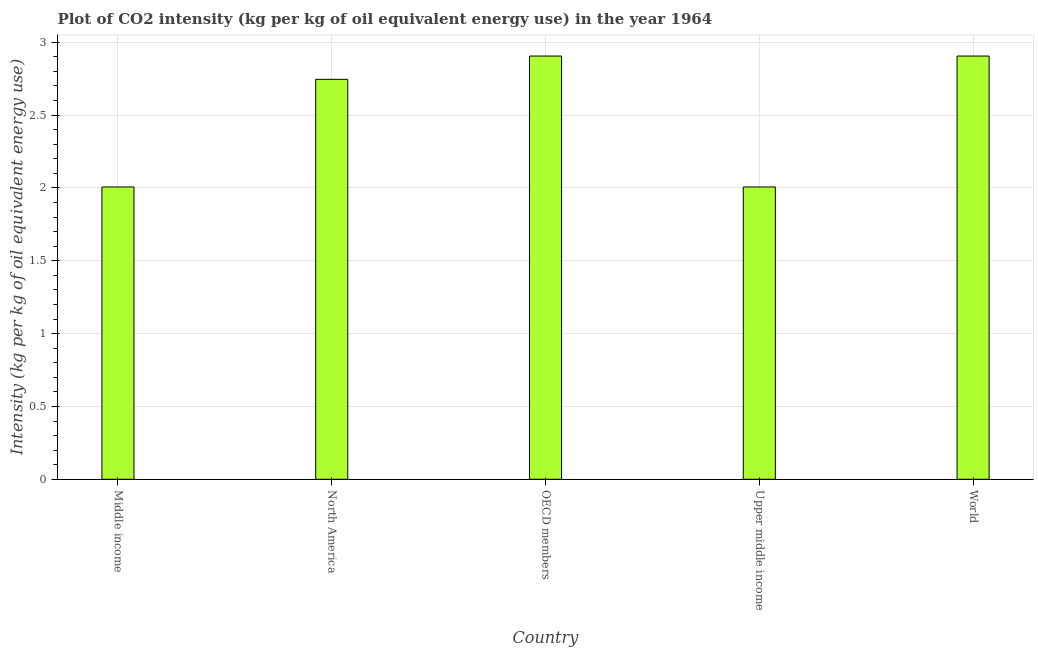Does the graph contain any zero values?
Your response must be concise. No. What is the title of the graph?
Keep it short and to the point. Plot of CO2 intensity (kg per kg of oil equivalent energy use) in the year 1964. What is the label or title of the Y-axis?
Ensure brevity in your answer.  Intensity (kg per kg of oil equivalent energy use). What is the co2 intensity in Upper middle income?
Provide a short and direct response. 2.01. Across all countries, what is the maximum co2 intensity?
Make the answer very short. 2.91. Across all countries, what is the minimum co2 intensity?
Your answer should be very brief. 2.01. In which country was the co2 intensity minimum?
Your answer should be very brief. Middle income. What is the sum of the co2 intensity?
Make the answer very short. 12.57. What is the difference between the co2 intensity in OECD members and World?
Offer a very short reply. 0. What is the average co2 intensity per country?
Offer a terse response. 2.51. What is the median co2 intensity?
Make the answer very short. 2.75. What is the ratio of the co2 intensity in Upper middle income to that in World?
Keep it short and to the point. 0.69. Is the difference between the co2 intensity in Middle income and North America greater than the difference between any two countries?
Give a very brief answer. No. Is the sum of the co2 intensity in Middle income and Upper middle income greater than the maximum co2 intensity across all countries?
Offer a very short reply. Yes. In how many countries, is the co2 intensity greater than the average co2 intensity taken over all countries?
Provide a short and direct response. 3. Are all the bars in the graph horizontal?
Give a very brief answer. No. How many countries are there in the graph?
Your response must be concise. 5. Are the values on the major ticks of Y-axis written in scientific E-notation?
Make the answer very short. No. What is the Intensity (kg per kg of oil equivalent energy use) of Middle income?
Your answer should be compact. 2.01. What is the Intensity (kg per kg of oil equivalent energy use) in North America?
Your response must be concise. 2.75. What is the Intensity (kg per kg of oil equivalent energy use) of OECD members?
Keep it short and to the point. 2.91. What is the Intensity (kg per kg of oil equivalent energy use) in Upper middle income?
Offer a terse response. 2.01. What is the Intensity (kg per kg of oil equivalent energy use) of World?
Provide a succinct answer. 2.91. What is the difference between the Intensity (kg per kg of oil equivalent energy use) in Middle income and North America?
Your response must be concise. -0.74. What is the difference between the Intensity (kg per kg of oil equivalent energy use) in Middle income and OECD members?
Ensure brevity in your answer.  -0.9. What is the difference between the Intensity (kg per kg of oil equivalent energy use) in Middle income and Upper middle income?
Provide a succinct answer. 0. What is the difference between the Intensity (kg per kg of oil equivalent energy use) in Middle income and World?
Your answer should be compact. -0.9. What is the difference between the Intensity (kg per kg of oil equivalent energy use) in North America and OECD members?
Give a very brief answer. -0.16. What is the difference between the Intensity (kg per kg of oil equivalent energy use) in North America and Upper middle income?
Your answer should be very brief. 0.74. What is the difference between the Intensity (kg per kg of oil equivalent energy use) in North America and World?
Your answer should be very brief. -0.16. What is the difference between the Intensity (kg per kg of oil equivalent energy use) in OECD members and Upper middle income?
Keep it short and to the point. 0.9. What is the difference between the Intensity (kg per kg of oil equivalent energy use) in OECD members and World?
Offer a very short reply. 0. What is the difference between the Intensity (kg per kg of oil equivalent energy use) in Upper middle income and World?
Offer a terse response. -0.9. What is the ratio of the Intensity (kg per kg of oil equivalent energy use) in Middle income to that in North America?
Give a very brief answer. 0.73. What is the ratio of the Intensity (kg per kg of oil equivalent energy use) in Middle income to that in OECD members?
Keep it short and to the point. 0.69. What is the ratio of the Intensity (kg per kg of oil equivalent energy use) in Middle income to that in World?
Your response must be concise. 0.69. What is the ratio of the Intensity (kg per kg of oil equivalent energy use) in North America to that in OECD members?
Make the answer very short. 0.94. What is the ratio of the Intensity (kg per kg of oil equivalent energy use) in North America to that in Upper middle income?
Your answer should be compact. 1.37. What is the ratio of the Intensity (kg per kg of oil equivalent energy use) in North America to that in World?
Your answer should be compact. 0.94. What is the ratio of the Intensity (kg per kg of oil equivalent energy use) in OECD members to that in Upper middle income?
Give a very brief answer. 1.45. What is the ratio of the Intensity (kg per kg of oil equivalent energy use) in OECD members to that in World?
Ensure brevity in your answer.  1. What is the ratio of the Intensity (kg per kg of oil equivalent energy use) in Upper middle income to that in World?
Your answer should be very brief. 0.69. 